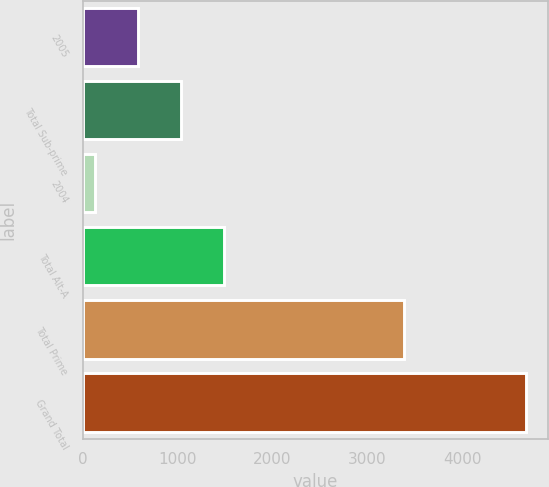Convert chart to OTSL. <chart><loc_0><loc_0><loc_500><loc_500><bar_chart><fcel>2005<fcel>Total Sub-prime<fcel>2004<fcel>Total Alt-A<fcel>Total Prime<fcel>Grand Total<nl><fcel>582.9<fcel>1036.8<fcel>129<fcel>1490.7<fcel>3383<fcel>4668<nl></chart> 